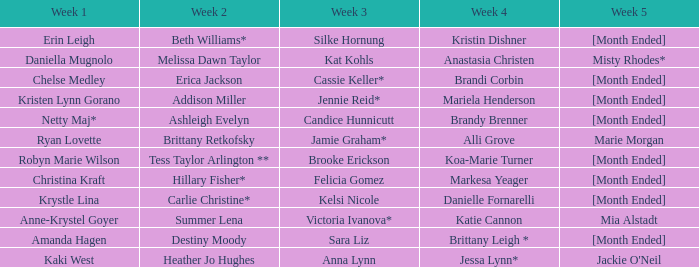What is the week 1 with candice hunnicutt in week 3? Netty Maj*. 